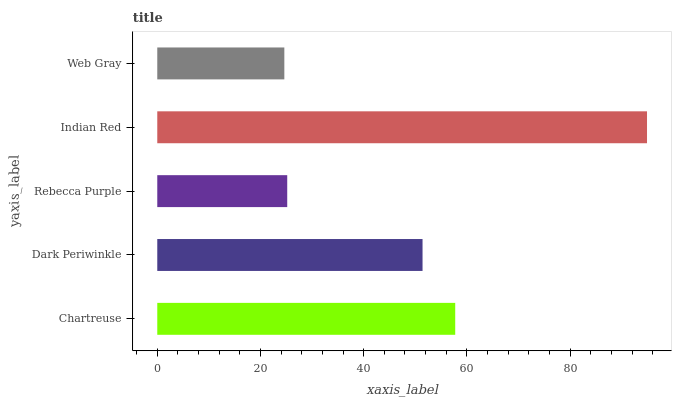Is Web Gray the minimum?
Answer yes or no. Yes. Is Indian Red the maximum?
Answer yes or no. Yes. Is Dark Periwinkle the minimum?
Answer yes or no. No. Is Dark Periwinkle the maximum?
Answer yes or no. No. Is Chartreuse greater than Dark Periwinkle?
Answer yes or no. Yes. Is Dark Periwinkle less than Chartreuse?
Answer yes or no. Yes. Is Dark Periwinkle greater than Chartreuse?
Answer yes or no. No. Is Chartreuse less than Dark Periwinkle?
Answer yes or no. No. Is Dark Periwinkle the high median?
Answer yes or no. Yes. Is Dark Periwinkle the low median?
Answer yes or no. Yes. Is Indian Red the high median?
Answer yes or no. No. Is Rebecca Purple the low median?
Answer yes or no. No. 